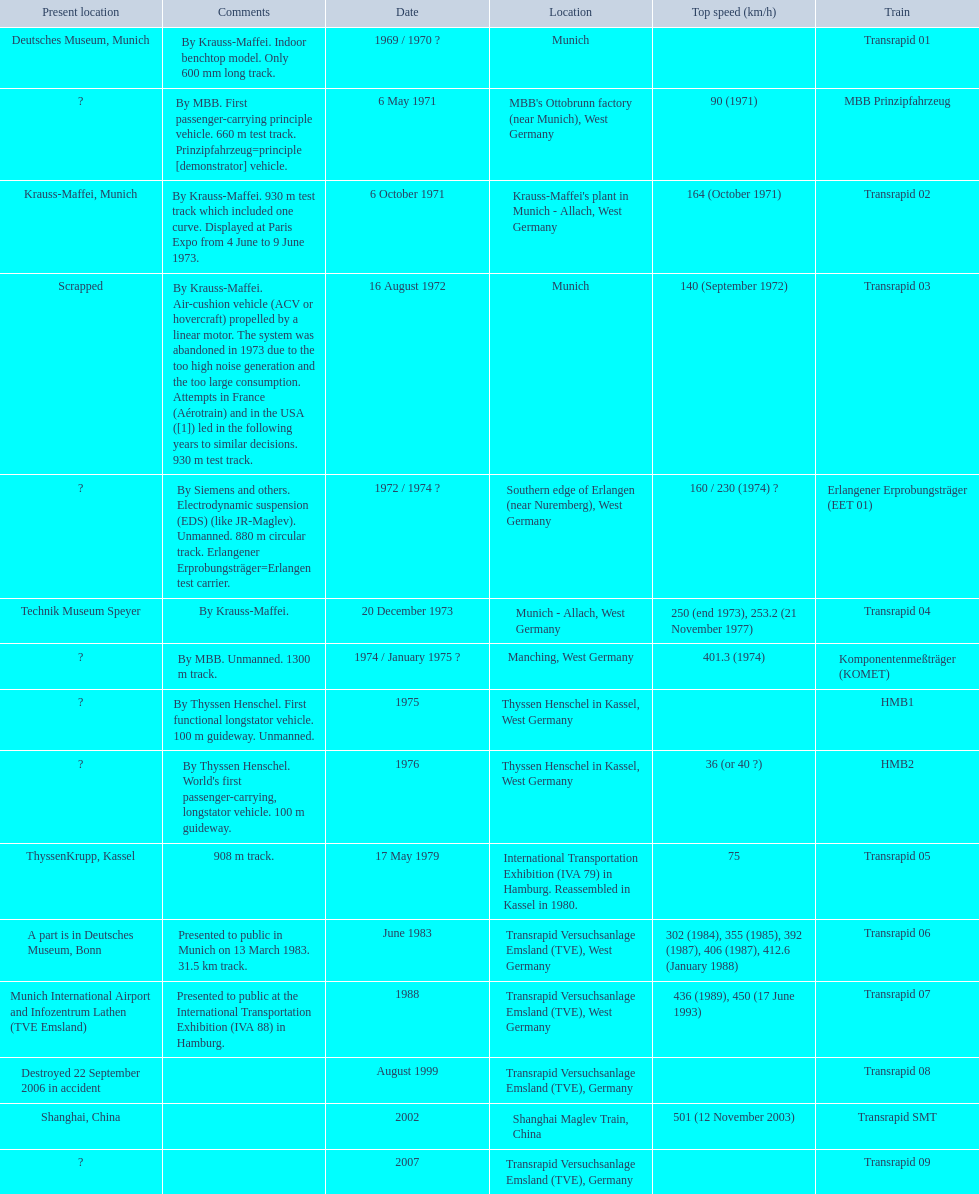What is the top speed reached by any trains shown here? 501 (12 November 2003). What train has reached a top speed of 501? Transrapid SMT. 